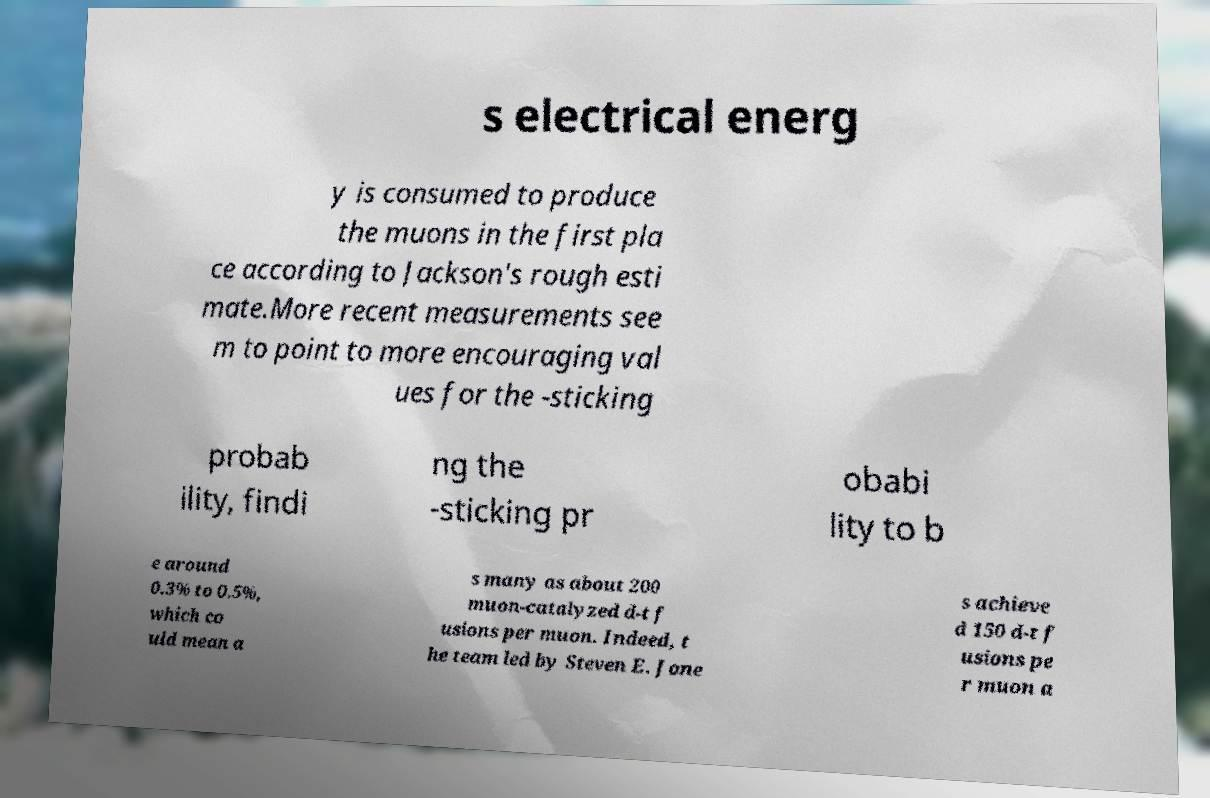There's text embedded in this image that I need extracted. Can you transcribe it verbatim? s electrical energ y is consumed to produce the muons in the first pla ce according to Jackson's rough esti mate.More recent measurements see m to point to more encouraging val ues for the -sticking probab ility, findi ng the -sticking pr obabi lity to b e around 0.3% to 0.5%, which co uld mean a s many as about 200 muon-catalyzed d-t f usions per muon. Indeed, t he team led by Steven E. Jone s achieve d 150 d-t f usions pe r muon a 